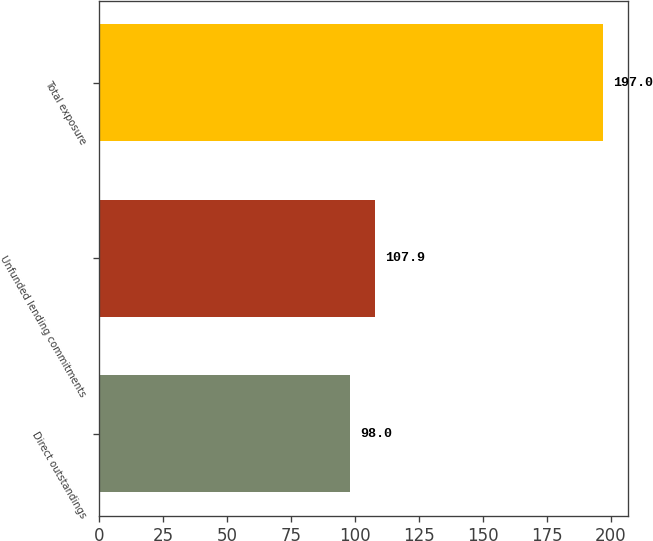Convert chart. <chart><loc_0><loc_0><loc_500><loc_500><bar_chart><fcel>Direct outstandings<fcel>Unfunded lending commitments<fcel>Total exposure<nl><fcel>98<fcel>107.9<fcel>197<nl></chart> 